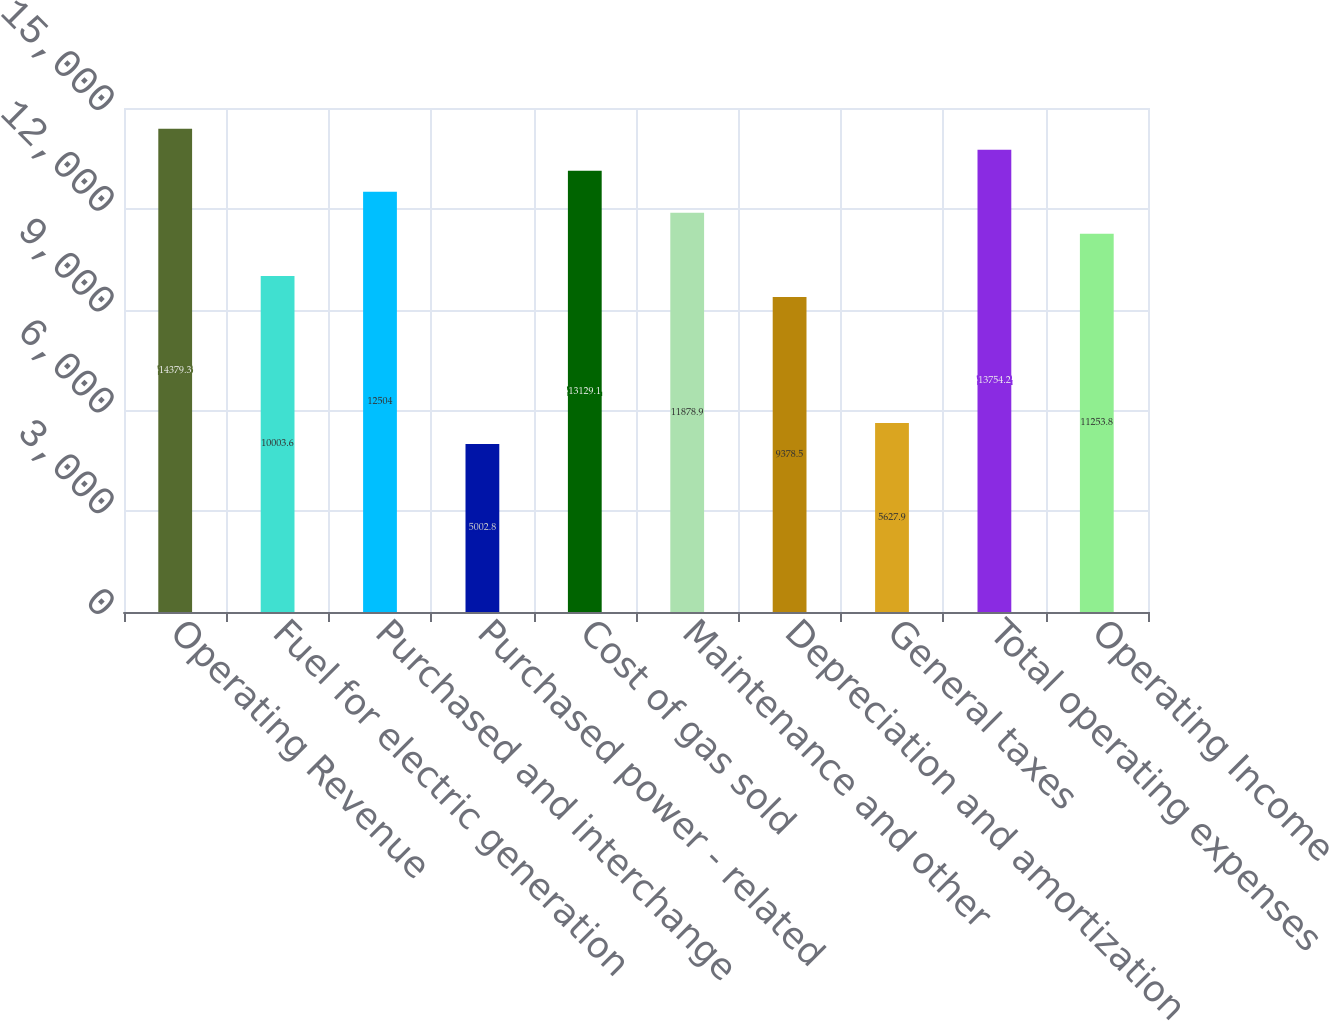<chart> <loc_0><loc_0><loc_500><loc_500><bar_chart><fcel>Operating Revenue<fcel>Fuel for electric generation<fcel>Purchased and interchange<fcel>Purchased power - related<fcel>Cost of gas sold<fcel>Maintenance and other<fcel>Depreciation and amortization<fcel>General taxes<fcel>Total operating expenses<fcel>Operating Income<nl><fcel>14379.3<fcel>10003.6<fcel>12504<fcel>5002.8<fcel>13129.1<fcel>11878.9<fcel>9378.5<fcel>5627.9<fcel>13754.2<fcel>11253.8<nl></chart> 